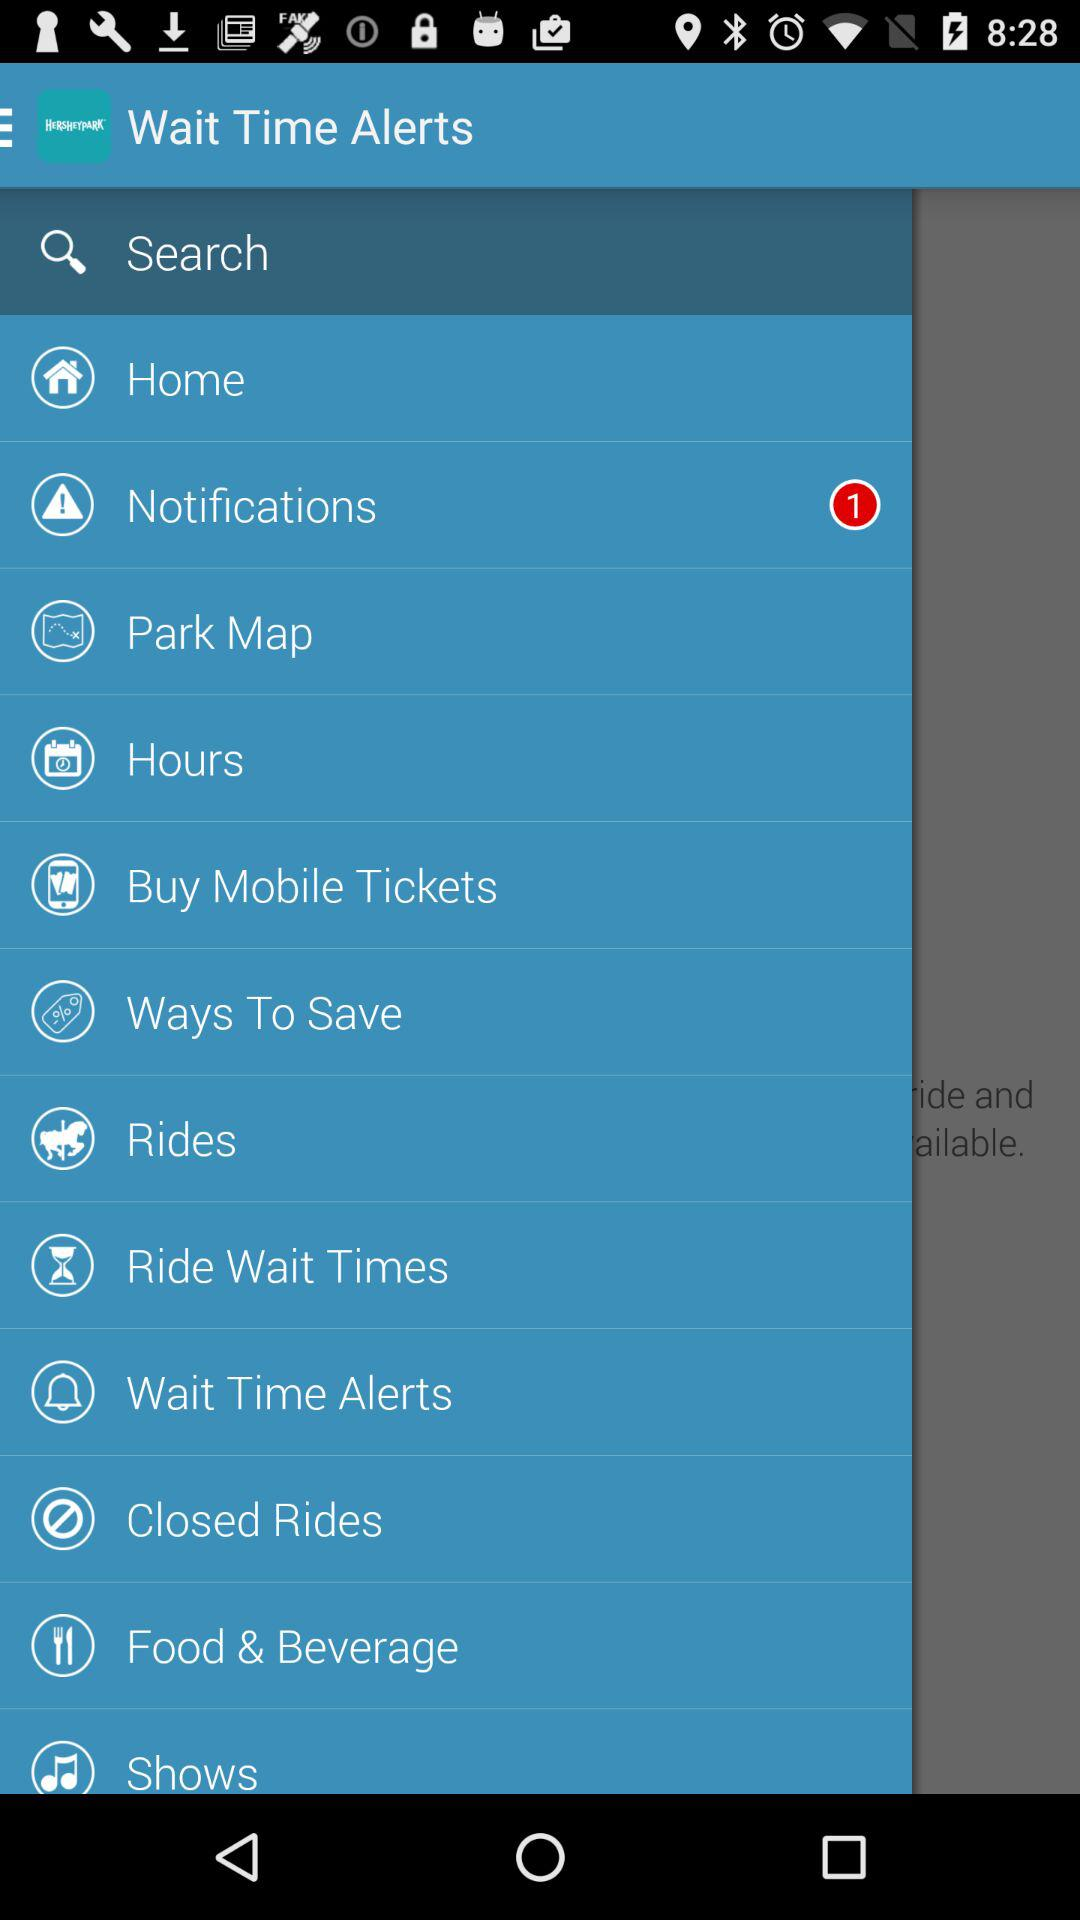How many new notifications are there? There is 1 new notification. 